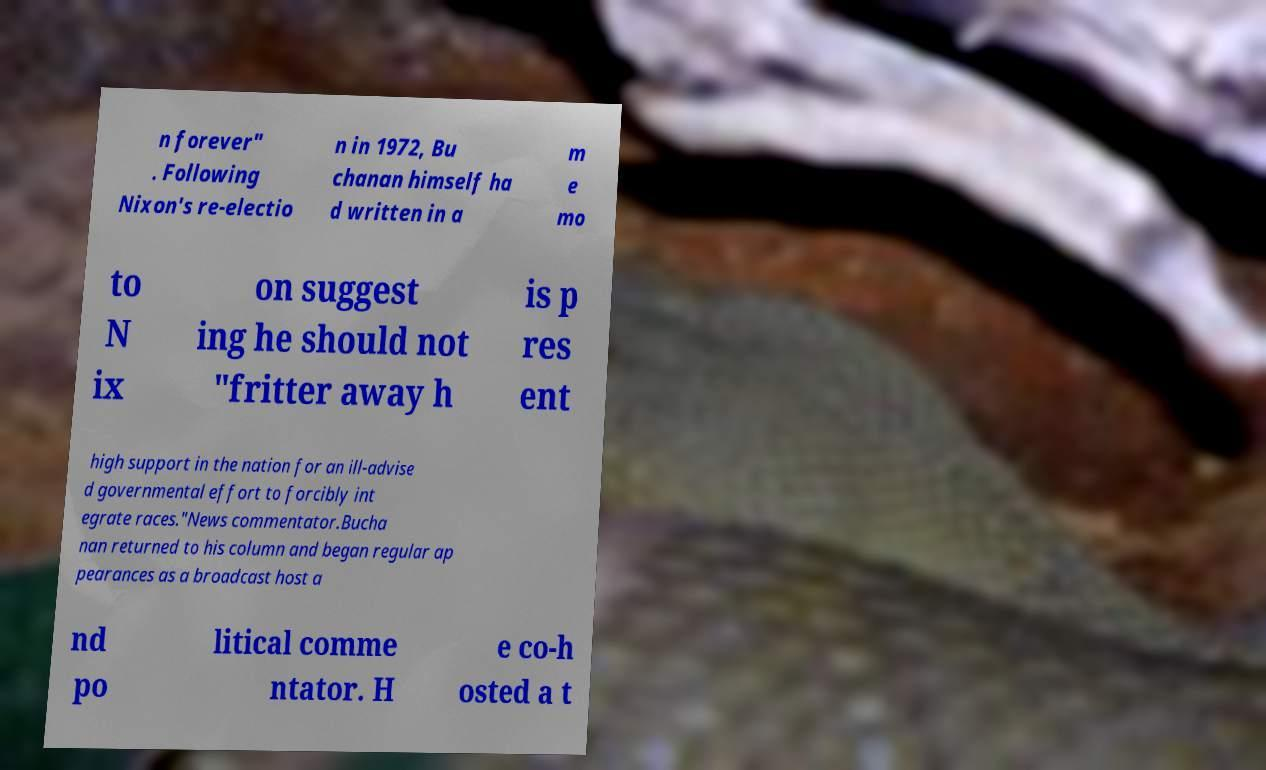There's text embedded in this image that I need extracted. Can you transcribe it verbatim? n forever" . Following Nixon's re-electio n in 1972, Bu chanan himself ha d written in a m e mo to N ix on suggest ing he should not "fritter away h is p res ent high support in the nation for an ill-advise d governmental effort to forcibly int egrate races."News commentator.Bucha nan returned to his column and began regular ap pearances as a broadcast host a nd po litical comme ntator. H e co-h osted a t 